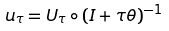<formula> <loc_0><loc_0><loc_500><loc_500>u _ { \tau } = U _ { \tau } \circ ( I + \tau \theta ) ^ { - 1 }</formula> 